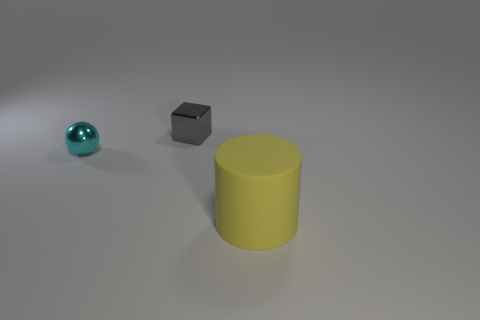Is there any other thing that is the same shape as the large yellow object?
Give a very brief answer. No. What is the size of the cylinder?
Keep it short and to the point. Large. There is another thing that is made of the same material as the tiny cyan object; what color is it?
Ensure brevity in your answer.  Gray. How many cyan objects are either large shiny cylinders or large things?
Offer a terse response. 0. Is the number of tiny yellow matte cylinders greater than the number of large yellow rubber cylinders?
Provide a succinct answer. No. How many things are either objects that are right of the gray metal block or things that are behind the large cylinder?
Make the answer very short. 3. The object that is the same size as the sphere is what color?
Provide a short and direct response. Gray. Does the small cyan ball have the same material as the large cylinder?
Ensure brevity in your answer.  No. There is a tiny thing that is behind the small object that is left of the small gray metallic object; what is its material?
Your answer should be very brief. Metal. Is the number of small metallic things on the right side of the small cyan metal sphere greater than the number of purple matte objects?
Give a very brief answer. Yes. 